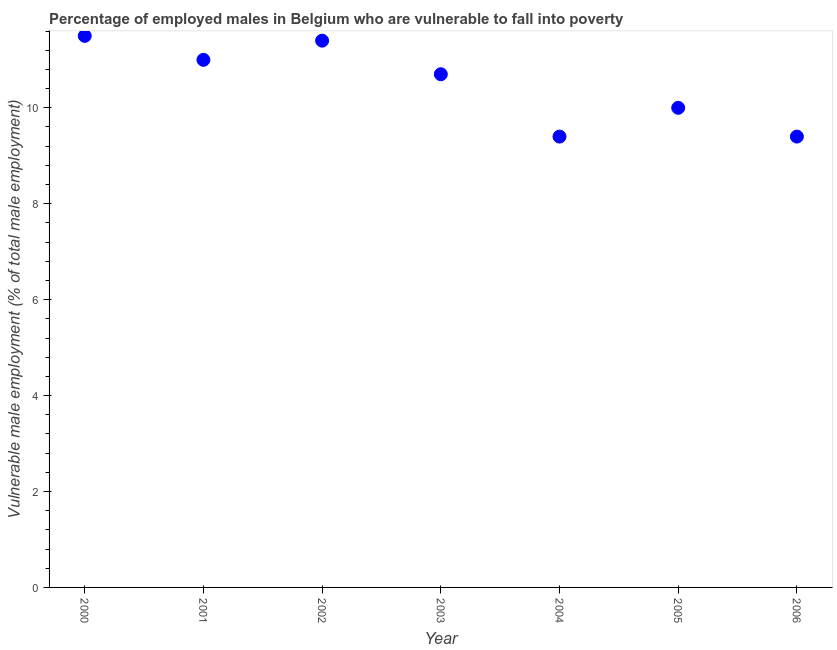What is the percentage of employed males who are vulnerable to fall into poverty in 2002?
Your answer should be very brief. 11.4. Across all years, what is the minimum percentage of employed males who are vulnerable to fall into poverty?
Offer a very short reply. 9.4. In which year was the percentage of employed males who are vulnerable to fall into poverty minimum?
Provide a succinct answer. 2004. What is the sum of the percentage of employed males who are vulnerable to fall into poverty?
Offer a very short reply. 73.4. What is the difference between the percentage of employed males who are vulnerable to fall into poverty in 2000 and 2001?
Your response must be concise. 0.5. What is the average percentage of employed males who are vulnerable to fall into poverty per year?
Offer a very short reply. 10.49. What is the median percentage of employed males who are vulnerable to fall into poverty?
Your response must be concise. 10.7. In how many years, is the percentage of employed males who are vulnerable to fall into poverty greater than 2 %?
Give a very brief answer. 7. Do a majority of the years between 2001 and 2006 (inclusive) have percentage of employed males who are vulnerable to fall into poverty greater than 10 %?
Provide a short and direct response. No. What is the ratio of the percentage of employed males who are vulnerable to fall into poverty in 2002 to that in 2003?
Your answer should be very brief. 1.07. What is the difference between the highest and the second highest percentage of employed males who are vulnerable to fall into poverty?
Offer a terse response. 0.1. What is the difference between the highest and the lowest percentage of employed males who are vulnerable to fall into poverty?
Give a very brief answer. 2.1. In how many years, is the percentage of employed males who are vulnerable to fall into poverty greater than the average percentage of employed males who are vulnerable to fall into poverty taken over all years?
Provide a succinct answer. 4. Does the percentage of employed males who are vulnerable to fall into poverty monotonically increase over the years?
Offer a terse response. No. What is the difference between two consecutive major ticks on the Y-axis?
Ensure brevity in your answer.  2. Does the graph contain grids?
Your answer should be compact. No. What is the title of the graph?
Provide a succinct answer. Percentage of employed males in Belgium who are vulnerable to fall into poverty. What is the label or title of the X-axis?
Make the answer very short. Year. What is the label or title of the Y-axis?
Give a very brief answer. Vulnerable male employment (% of total male employment). What is the Vulnerable male employment (% of total male employment) in 2001?
Your answer should be compact. 11. What is the Vulnerable male employment (% of total male employment) in 2002?
Make the answer very short. 11.4. What is the Vulnerable male employment (% of total male employment) in 2003?
Offer a terse response. 10.7. What is the Vulnerable male employment (% of total male employment) in 2004?
Your answer should be very brief. 9.4. What is the Vulnerable male employment (% of total male employment) in 2006?
Your response must be concise. 9.4. What is the difference between the Vulnerable male employment (% of total male employment) in 2000 and 2002?
Offer a very short reply. 0.1. What is the difference between the Vulnerable male employment (% of total male employment) in 2001 and 2004?
Ensure brevity in your answer.  1.6. What is the difference between the Vulnerable male employment (% of total male employment) in 2001 and 2005?
Provide a short and direct response. 1. What is the difference between the Vulnerable male employment (% of total male employment) in 2001 and 2006?
Provide a short and direct response. 1.6. What is the difference between the Vulnerable male employment (% of total male employment) in 2002 and 2004?
Offer a terse response. 2. What is the difference between the Vulnerable male employment (% of total male employment) in 2003 and 2005?
Keep it short and to the point. 0.7. What is the difference between the Vulnerable male employment (% of total male employment) in 2003 and 2006?
Your answer should be very brief. 1.3. What is the difference between the Vulnerable male employment (% of total male employment) in 2005 and 2006?
Provide a short and direct response. 0.6. What is the ratio of the Vulnerable male employment (% of total male employment) in 2000 to that in 2001?
Provide a succinct answer. 1.04. What is the ratio of the Vulnerable male employment (% of total male employment) in 2000 to that in 2002?
Keep it short and to the point. 1.01. What is the ratio of the Vulnerable male employment (% of total male employment) in 2000 to that in 2003?
Ensure brevity in your answer.  1.07. What is the ratio of the Vulnerable male employment (% of total male employment) in 2000 to that in 2004?
Offer a terse response. 1.22. What is the ratio of the Vulnerable male employment (% of total male employment) in 2000 to that in 2005?
Give a very brief answer. 1.15. What is the ratio of the Vulnerable male employment (% of total male employment) in 2000 to that in 2006?
Offer a terse response. 1.22. What is the ratio of the Vulnerable male employment (% of total male employment) in 2001 to that in 2002?
Provide a succinct answer. 0.96. What is the ratio of the Vulnerable male employment (% of total male employment) in 2001 to that in 2003?
Keep it short and to the point. 1.03. What is the ratio of the Vulnerable male employment (% of total male employment) in 2001 to that in 2004?
Ensure brevity in your answer.  1.17. What is the ratio of the Vulnerable male employment (% of total male employment) in 2001 to that in 2006?
Keep it short and to the point. 1.17. What is the ratio of the Vulnerable male employment (% of total male employment) in 2002 to that in 2003?
Your answer should be compact. 1.06. What is the ratio of the Vulnerable male employment (% of total male employment) in 2002 to that in 2004?
Offer a very short reply. 1.21. What is the ratio of the Vulnerable male employment (% of total male employment) in 2002 to that in 2005?
Give a very brief answer. 1.14. What is the ratio of the Vulnerable male employment (% of total male employment) in 2002 to that in 2006?
Provide a succinct answer. 1.21. What is the ratio of the Vulnerable male employment (% of total male employment) in 2003 to that in 2004?
Your response must be concise. 1.14. What is the ratio of the Vulnerable male employment (% of total male employment) in 2003 to that in 2005?
Offer a terse response. 1.07. What is the ratio of the Vulnerable male employment (% of total male employment) in 2003 to that in 2006?
Make the answer very short. 1.14. What is the ratio of the Vulnerable male employment (% of total male employment) in 2004 to that in 2005?
Your response must be concise. 0.94. What is the ratio of the Vulnerable male employment (% of total male employment) in 2005 to that in 2006?
Make the answer very short. 1.06. 